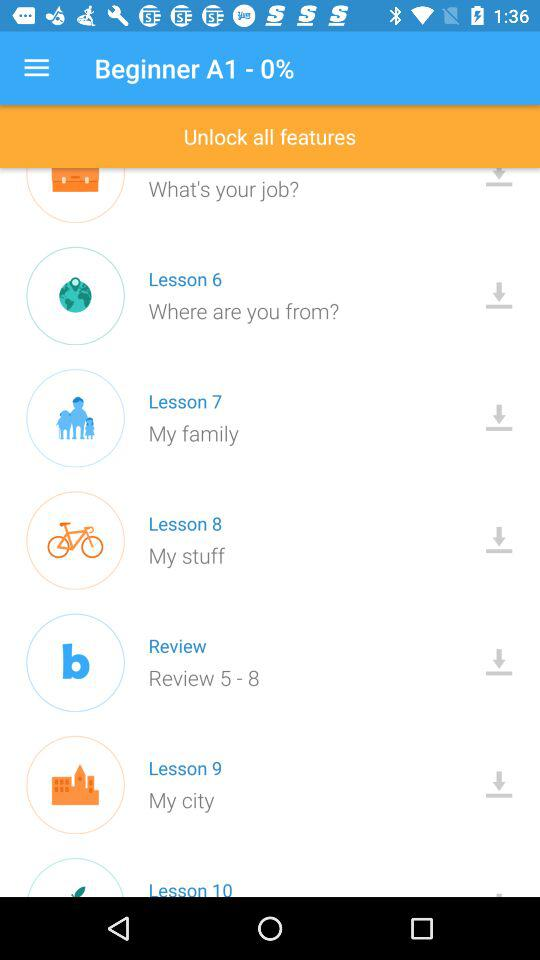What lesson contains "My stuff"? The lesson is 8. 